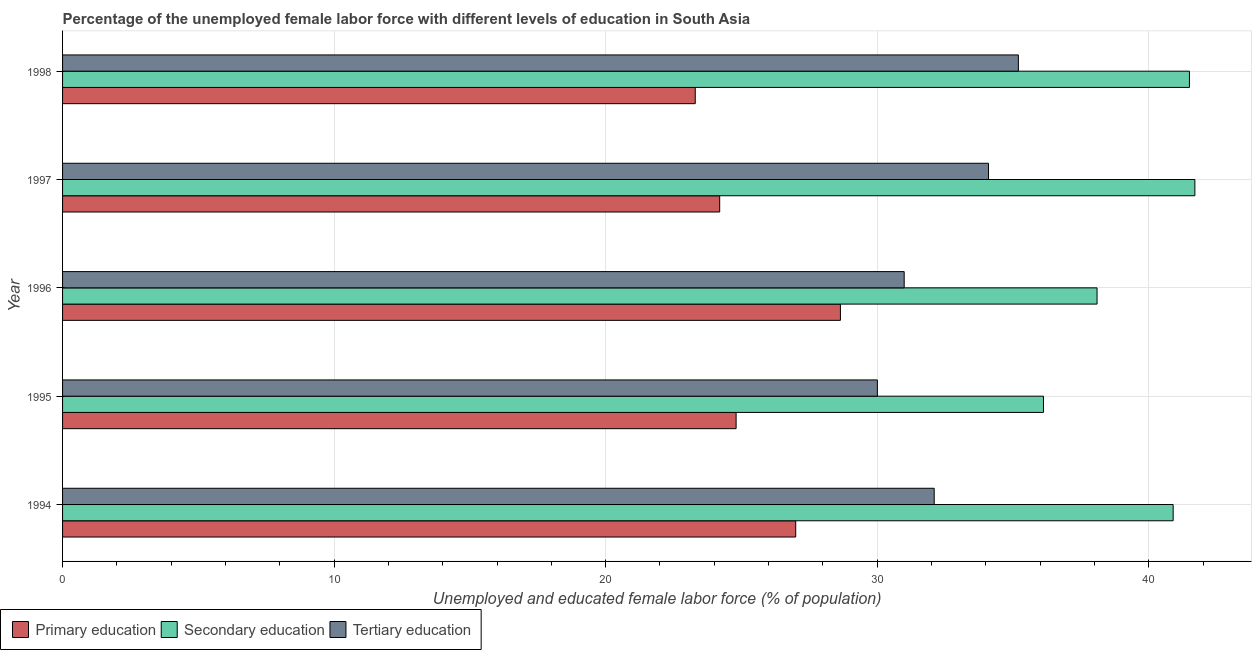How many different coloured bars are there?
Your answer should be very brief. 3. How many groups of bars are there?
Offer a terse response. 5. Are the number of bars on each tick of the Y-axis equal?
Offer a very short reply. Yes. How many bars are there on the 5th tick from the top?
Your response must be concise. 3. How many bars are there on the 2nd tick from the bottom?
Your answer should be very brief. 3. What is the label of the 1st group of bars from the top?
Make the answer very short. 1998. What is the percentage of female labor force who received tertiary education in 1997?
Keep it short and to the point. 34.1. Across all years, what is the maximum percentage of female labor force who received tertiary education?
Provide a short and direct response. 35.2. Across all years, what is the minimum percentage of female labor force who received primary education?
Your answer should be compact. 23.3. In which year was the percentage of female labor force who received secondary education maximum?
Make the answer very short. 1997. In which year was the percentage of female labor force who received tertiary education minimum?
Give a very brief answer. 1995. What is the total percentage of female labor force who received primary education in the graph?
Keep it short and to the point. 127.95. What is the difference between the percentage of female labor force who received tertiary education in 1995 and the percentage of female labor force who received primary education in 1997?
Your answer should be compact. 5.81. What is the average percentage of female labor force who received primary education per year?
Provide a short and direct response. 25.59. In the year 1998, what is the difference between the percentage of female labor force who received secondary education and percentage of female labor force who received tertiary education?
Keep it short and to the point. 6.3. In how many years, is the percentage of female labor force who received primary education greater than 32 %?
Offer a terse response. 0. What is the ratio of the percentage of female labor force who received secondary education in 1994 to that in 1995?
Your answer should be compact. 1.13. What is the difference between the highest and the second highest percentage of female labor force who received primary education?
Your answer should be compact. 1.65. What is the difference between the highest and the lowest percentage of female labor force who received tertiary education?
Provide a short and direct response. 5.19. What does the 2nd bar from the top in 1996 represents?
Ensure brevity in your answer.  Secondary education. What does the 3rd bar from the bottom in 1994 represents?
Ensure brevity in your answer.  Tertiary education. How many bars are there?
Offer a terse response. 15. Are all the bars in the graph horizontal?
Your answer should be compact. Yes. Does the graph contain any zero values?
Keep it short and to the point. No. Does the graph contain grids?
Your answer should be compact. Yes. Where does the legend appear in the graph?
Make the answer very short. Bottom left. How many legend labels are there?
Keep it short and to the point. 3. How are the legend labels stacked?
Ensure brevity in your answer.  Horizontal. What is the title of the graph?
Ensure brevity in your answer.  Percentage of the unemployed female labor force with different levels of education in South Asia. Does "Taxes" appear as one of the legend labels in the graph?
Your answer should be compact. No. What is the label or title of the X-axis?
Keep it short and to the point. Unemployed and educated female labor force (% of population). What is the Unemployed and educated female labor force (% of population) in Secondary education in 1994?
Ensure brevity in your answer.  40.9. What is the Unemployed and educated female labor force (% of population) in Tertiary education in 1994?
Provide a succinct answer. 32.1. What is the Unemployed and educated female labor force (% of population) in Primary education in 1995?
Keep it short and to the point. 24.8. What is the Unemployed and educated female labor force (% of population) of Secondary education in 1995?
Give a very brief answer. 36.12. What is the Unemployed and educated female labor force (% of population) in Tertiary education in 1995?
Offer a terse response. 30.01. What is the Unemployed and educated female labor force (% of population) of Primary education in 1996?
Offer a very short reply. 28.65. What is the Unemployed and educated female labor force (% of population) of Secondary education in 1996?
Offer a terse response. 38.1. What is the Unemployed and educated female labor force (% of population) of Tertiary education in 1996?
Ensure brevity in your answer.  30.99. What is the Unemployed and educated female labor force (% of population) of Primary education in 1997?
Your response must be concise. 24.2. What is the Unemployed and educated female labor force (% of population) in Secondary education in 1997?
Offer a very short reply. 41.7. What is the Unemployed and educated female labor force (% of population) of Tertiary education in 1997?
Your answer should be very brief. 34.1. What is the Unemployed and educated female labor force (% of population) in Primary education in 1998?
Keep it short and to the point. 23.3. What is the Unemployed and educated female labor force (% of population) in Secondary education in 1998?
Make the answer very short. 41.5. What is the Unemployed and educated female labor force (% of population) in Tertiary education in 1998?
Your response must be concise. 35.2. Across all years, what is the maximum Unemployed and educated female labor force (% of population) in Primary education?
Offer a very short reply. 28.65. Across all years, what is the maximum Unemployed and educated female labor force (% of population) of Secondary education?
Keep it short and to the point. 41.7. Across all years, what is the maximum Unemployed and educated female labor force (% of population) of Tertiary education?
Give a very brief answer. 35.2. Across all years, what is the minimum Unemployed and educated female labor force (% of population) of Primary education?
Provide a short and direct response. 23.3. Across all years, what is the minimum Unemployed and educated female labor force (% of population) in Secondary education?
Your answer should be very brief. 36.12. Across all years, what is the minimum Unemployed and educated female labor force (% of population) in Tertiary education?
Make the answer very short. 30.01. What is the total Unemployed and educated female labor force (% of population) in Primary education in the graph?
Make the answer very short. 127.95. What is the total Unemployed and educated female labor force (% of population) of Secondary education in the graph?
Keep it short and to the point. 198.32. What is the total Unemployed and educated female labor force (% of population) in Tertiary education in the graph?
Offer a terse response. 162.4. What is the difference between the Unemployed and educated female labor force (% of population) of Primary education in 1994 and that in 1995?
Your answer should be compact. 2.2. What is the difference between the Unemployed and educated female labor force (% of population) of Secondary education in 1994 and that in 1995?
Offer a terse response. 4.78. What is the difference between the Unemployed and educated female labor force (% of population) in Tertiary education in 1994 and that in 1995?
Give a very brief answer. 2.09. What is the difference between the Unemployed and educated female labor force (% of population) of Primary education in 1994 and that in 1996?
Offer a very short reply. -1.65. What is the difference between the Unemployed and educated female labor force (% of population) in Secondary education in 1994 and that in 1996?
Offer a terse response. 2.8. What is the difference between the Unemployed and educated female labor force (% of population) of Tertiary education in 1994 and that in 1996?
Your answer should be compact. 1.11. What is the difference between the Unemployed and educated female labor force (% of population) in Tertiary education in 1994 and that in 1997?
Offer a very short reply. -2. What is the difference between the Unemployed and educated female labor force (% of population) in Primary education in 1994 and that in 1998?
Your response must be concise. 3.7. What is the difference between the Unemployed and educated female labor force (% of population) in Secondary education in 1994 and that in 1998?
Give a very brief answer. -0.6. What is the difference between the Unemployed and educated female labor force (% of population) in Primary education in 1995 and that in 1996?
Make the answer very short. -3.84. What is the difference between the Unemployed and educated female labor force (% of population) of Secondary education in 1995 and that in 1996?
Make the answer very short. -1.97. What is the difference between the Unemployed and educated female labor force (% of population) of Tertiary education in 1995 and that in 1996?
Ensure brevity in your answer.  -0.99. What is the difference between the Unemployed and educated female labor force (% of population) of Primary education in 1995 and that in 1997?
Your response must be concise. 0.6. What is the difference between the Unemployed and educated female labor force (% of population) of Secondary education in 1995 and that in 1997?
Offer a very short reply. -5.58. What is the difference between the Unemployed and educated female labor force (% of population) of Tertiary education in 1995 and that in 1997?
Your answer should be compact. -4.09. What is the difference between the Unemployed and educated female labor force (% of population) in Primary education in 1995 and that in 1998?
Provide a short and direct response. 1.5. What is the difference between the Unemployed and educated female labor force (% of population) of Secondary education in 1995 and that in 1998?
Your answer should be very brief. -5.38. What is the difference between the Unemployed and educated female labor force (% of population) in Tertiary education in 1995 and that in 1998?
Keep it short and to the point. -5.19. What is the difference between the Unemployed and educated female labor force (% of population) of Primary education in 1996 and that in 1997?
Your answer should be compact. 4.45. What is the difference between the Unemployed and educated female labor force (% of population) in Secondary education in 1996 and that in 1997?
Give a very brief answer. -3.6. What is the difference between the Unemployed and educated female labor force (% of population) in Tertiary education in 1996 and that in 1997?
Your answer should be very brief. -3.11. What is the difference between the Unemployed and educated female labor force (% of population) of Primary education in 1996 and that in 1998?
Ensure brevity in your answer.  5.35. What is the difference between the Unemployed and educated female labor force (% of population) of Secondary education in 1996 and that in 1998?
Keep it short and to the point. -3.4. What is the difference between the Unemployed and educated female labor force (% of population) of Tertiary education in 1996 and that in 1998?
Keep it short and to the point. -4.21. What is the difference between the Unemployed and educated female labor force (% of population) of Primary education in 1997 and that in 1998?
Provide a succinct answer. 0.9. What is the difference between the Unemployed and educated female labor force (% of population) in Secondary education in 1997 and that in 1998?
Your answer should be compact. 0.2. What is the difference between the Unemployed and educated female labor force (% of population) of Tertiary education in 1997 and that in 1998?
Give a very brief answer. -1.1. What is the difference between the Unemployed and educated female labor force (% of population) of Primary education in 1994 and the Unemployed and educated female labor force (% of population) of Secondary education in 1995?
Ensure brevity in your answer.  -9.12. What is the difference between the Unemployed and educated female labor force (% of population) in Primary education in 1994 and the Unemployed and educated female labor force (% of population) in Tertiary education in 1995?
Provide a short and direct response. -3.01. What is the difference between the Unemployed and educated female labor force (% of population) in Secondary education in 1994 and the Unemployed and educated female labor force (% of population) in Tertiary education in 1995?
Provide a succinct answer. 10.89. What is the difference between the Unemployed and educated female labor force (% of population) of Primary education in 1994 and the Unemployed and educated female labor force (% of population) of Secondary education in 1996?
Your response must be concise. -11.1. What is the difference between the Unemployed and educated female labor force (% of population) of Primary education in 1994 and the Unemployed and educated female labor force (% of population) of Tertiary education in 1996?
Your response must be concise. -3.99. What is the difference between the Unemployed and educated female labor force (% of population) of Secondary education in 1994 and the Unemployed and educated female labor force (% of population) of Tertiary education in 1996?
Your answer should be very brief. 9.91. What is the difference between the Unemployed and educated female labor force (% of population) of Primary education in 1994 and the Unemployed and educated female labor force (% of population) of Secondary education in 1997?
Offer a very short reply. -14.7. What is the difference between the Unemployed and educated female labor force (% of population) in Secondary education in 1994 and the Unemployed and educated female labor force (% of population) in Tertiary education in 1997?
Your answer should be very brief. 6.8. What is the difference between the Unemployed and educated female labor force (% of population) of Primary education in 1994 and the Unemployed and educated female labor force (% of population) of Secondary education in 1998?
Make the answer very short. -14.5. What is the difference between the Unemployed and educated female labor force (% of population) in Secondary education in 1994 and the Unemployed and educated female labor force (% of population) in Tertiary education in 1998?
Offer a terse response. 5.7. What is the difference between the Unemployed and educated female labor force (% of population) in Primary education in 1995 and the Unemployed and educated female labor force (% of population) in Secondary education in 1996?
Make the answer very short. -13.29. What is the difference between the Unemployed and educated female labor force (% of population) in Primary education in 1995 and the Unemployed and educated female labor force (% of population) in Tertiary education in 1996?
Your answer should be very brief. -6.19. What is the difference between the Unemployed and educated female labor force (% of population) in Secondary education in 1995 and the Unemployed and educated female labor force (% of population) in Tertiary education in 1996?
Make the answer very short. 5.13. What is the difference between the Unemployed and educated female labor force (% of population) in Primary education in 1995 and the Unemployed and educated female labor force (% of population) in Secondary education in 1997?
Keep it short and to the point. -16.9. What is the difference between the Unemployed and educated female labor force (% of population) in Primary education in 1995 and the Unemployed and educated female labor force (% of population) in Tertiary education in 1997?
Provide a succinct answer. -9.3. What is the difference between the Unemployed and educated female labor force (% of population) of Secondary education in 1995 and the Unemployed and educated female labor force (% of population) of Tertiary education in 1997?
Your answer should be compact. 2.02. What is the difference between the Unemployed and educated female labor force (% of population) of Primary education in 1995 and the Unemployed and educated female labor force (% of population) of Secondary education in 1998?
Your response must be concise. -16.7. What is the difference between the Unemployed and educated female labor force (% of population) in Primary education in 1995 and the Unemployed and educated female labor force (% of population) in Tertiary education in 1998?
Keep it short and to the point. -10.4. What is the difference between the Unemployed and educated female labor force (% of population) of Secondary education in 1995 and the Unemployed and educated female labor force (% of population) of Tertiary education in 1998?
Provide a short and direct response. 0.92. What is the difference between the Unemployed and educated female labor force (% of population) in Primary education in 1996 and the Unemployed and educated female labor force (% of population) in Secondary education in 1997?
Offer a very short reply. -13.05. What is the difference between the Unemployed and educated female labor force (% of population) of Primary education in 1996 and the Unemployed and educated female labor force (% of population) of Tertiary education in 1997?
Keep it short and to the point. -5.45. What is the difference between the Unemployed and educated female labor force (% of population) in Secondary education in 1996 and the Unemployed and educated female labor force (% of population) in Tertiary education in 1997?
Give a very brief answer. 4. What is the difference between the Unemployed and educated female labor force (% of population) of Primary education in 1996 and the Unemployed and educated female labor force (% of population) of Secondary education in 1998?
Make the answer very short. -12.85. What is the difference between the Unemployed and educated female labor force (% of population) in Primary education in 1996 and the Unemployed and educated female labor force (% of population) in Tertiary education in 1998?
Offer a terse response. -6.55. What is the difference between the Unemployed and educated female labor force (% of population) of Secondary education in 1996 and the Unemployed and educated female labor force (% of population) of Tertiary education in 1998?
Provide a succinct answer. 2.9. What is the difference between the Unemployed and educated female labor force (% of population) of Primary education in 1997 and the Unemployed and educated female labor force (% of population) of Secondary education in 1998?
Offer a terse response. -17.3. What is the difference between the Unemployed and educated female labor force (% of population) in Secondary education in 1997 and the Unemployed and educated female labor force (% of population) in Tertiary education in 1998?
Offer a very short reply. 6.5. What is the average Unemployed and educated female labor force (% of population) in Primary education per year?
Offer a very short reply. 25.59. What is the average Unemployed and educated female labor force (% of population) of Secondary education per year?
Provide a short and direct response. 39.66. What is the average Unemployed and educated female labor force (% of population) of Tertiary education per year?
Make the answer very short. 32.48. In the year 1994, what is the difference between the Unemployed and educated female labor force (% of population) of Primary education and Unemployed and educated female labor force (% of population) of Tertiary education?
Provide a short and direct response. -5.1. In the year 1994, what is the difference between the Unemployed and educated female labor force (% of population) in Secondary education and Unemployed and educated female labor force (% of population) in Tertiary education?
Give a very brief answer. 8.8. In the year 1995, what is the difference between the Unemployed and educated female labor force (% of population) of Primary education and Unemployed and educated female labor force (% of population) of Secondary education?
Provide a short and direct response. -11.32. In the year 1995, what is the difference between the Unemployed and educated female labor force (% of population) of Primary education and Unemployed and educated female labor force (% of population) of Tertiary education?
Your answer should be very brief. -5.2. In the year 1995, what is the difference between the Unemployed and educated female labor force (% of population) of Secondary education and Unemployed and educated female labor force (% of population) of Tertiary education?
Offer a terse response. 6.12. In the year 1996, what is the difference between the Unemployed and educated female labor force (% of population) of Primary education and Unemployed and educated female labor force (% of population) of Secondary education?
Offer a very short reply. -9.45. In the year 1996, what is the difference between the Unemployed and educated female labor force (% of population) of Primary education and Unemployed and educated female labor force (% of population) of Tertiary education?
Your answer should be compact. -2.35. In the year 1996, what is the difference between the Unemployed and educated female labor force (% of population) in Secondary education and Unemployed and educated female labor force (% of population) in Tertiary education?
Keep it short and to the point. 7.1. In the year 1997, what is the difference between the Unemployed and educated female labor force (% of population) of Primary education and Unemployed and educated female labor force (% of population) of Secondary education?
Your response must be concise. -17.5. In the year 1997, what is the difference between the Unemployed and educated female labor force (% of population) of Primary education and Unemployed and educated female labor force (% of population) of Tertiary education?
Keep it short and to the point. -9.9. In the year 1997, what is the difference between the Unemployed and educated female labor force (% of population) of Secondary education and Unemployed and educated female labor force (% of population) of Tertiary education?
Your answer should be compact. 7.6. In the year 1998, what is the difference between the Unemployed and educated female labor force (% of population) in Primary education and Unemployed and educated female labor force (% of population) in Secondary education?
Ensure brevity in your answer.  -18.2. In the year 1998, what is the difference between the Unemployed and educated female labor force (% of population) in Secondary education and Unemployed and educated female labor force (% of population) in Tertiary education?
Keep it short and to the point. 6.3. What is the ratio of the Unemployed and educated female labor force (% of population) in Primary education in 1994 to that in 1995?
Offer a terse response. 1.09. What is the ratio of the Unemployed and educated female labor force (% of population) of Secondary education in 1994 to that in 1995?
Offer a very short reply. 1.13. What is the ratio of the Unemployed and educated female labor force (% of population) in Tertiary education in 1994 to that in 1995?
Your answer should be very brief. 1.07. What is the ratio of the Unemployed and educated female labor force (% of population) in Primary education in 1994 to that in 1996?
Your response must be concise. 0.94. What is the ratio of the Unemployed and educated female labor force (% of population) of Secondary education in 1994 to that in 1996?
Provide a succinct answer. 1.07. What is the ratio of the Unemployed and educated female labor force (% of population) in Tertiary education in 1994 to that in 1996?
Your answer should be compact. 1.04. What is the ratio of the Unemployed and educated female labor force (% of population) in Primary education in 1994 to that in 1997?
Your answer should be very brief. 1.12. What is the ratio of the Unemployed and educated female labor force (% of population) in Secondary education in 1994 to that in 1997?
Make the answer very short. 0.98. What is the ratio of the Unemployed and educated female labor force (% of population) in Tertiary education in 1994 to that in 1997?
Your answer should be very brief. 0.94. What is the ratio of the Unemployed and educated female labor force (% of population) in Primary education in 1994 to that in 1998?
Offer a very short reply. 1.16. What is the ratio of the Unemployed and educated female labor force (% of population) in Secondary education in 1994 to that in 1998?
Your answer should be very brief. 0.99. What is the ratio of the Unemployed and educated female labor force (% of population) in Tertiary education in 1994 to that in 1998?
Your response must be concise. 0.91. What is the ratio of the Unemployed and educated female labor force (% of population) in Primary education in 1995 to that in 1996?
Offer a terse response. 0.87. What is the ratio of the Unemployed and educated female labor force (% of population) of Secondary education in 1995 to that in 1996?
Provide a succinct answer. 0.95. What is the ratio of the Unemployed and educated female labor force (% of population) in Tertiary education in 1995 to that in 1996?
Keep it short and to the point. 0.97. What is the ratio of the Unemployed and educated female labor force (% of population) in Primary education in 1995 to that in 1997?
Keep it short and to the point. 1.02. What is the ratio of the Unemployed and educated female labor force (% of population) in Secondary education in 1995 to that in 1997?
Provide a short and direct response. 0.87. What is the ratio of the Unemployed and educated female labor force (% of population) in Primary education in 1995 to that in 1998?
Ensure brevity in your answer.  1.06. What is the ratio of the Unemployed and educated female labor force (% of population) in Secondary education in 1995 to that in 1998?
Ensure brevity in your answer.  0.87. What is the ratio of the Unemployed and educated female labor force (% of population) of Tertiary education in 1995 to that in 1998?
Your response must be concise. 0.85. What is the ratio of the Unemployed and educated female labor force (% of population) of Primary education in 1996 to that in 1997?
Make the answer very short. 1.18. What is the ratio of the Unemployed and educated female labor force (% of population) of Secondary education in 1996 to that in 1997?
Provide a short and direct response. 0.91. What is the ratio of the Unemployed and educated female labor force (% of population) of Tertiary education in 1996 to that in 1997?
Offer a terse response. 0.91. What is the ratio of the Unemployed and educated female labor force (% of population) in Primary education in 1996 to that in 1998?
Offer a very short reply. 1.23. What is the ratio of the Unemployed and educated female labor force (% of population) in Secondary education in 1996 to that in 1998?
Make the answer very short. 0.92. What is the ratio of the Unemployed and educated female labor force (% of population) of Tertiary education in 1996 to that in 1998?
Keep it short and to the point. 0.88. What is the ratio of the Unemployed and educated female labor force (% of population) of Primary education in 1997 to that in 1998?
Offer a terse response. 1.04. What is the ratio of the Unemployed and educated female labor force (% of population) in Secondary education in 1997 to that in 1998?
Ensure brevity in your answer.  1. What is the ratio of the Unemployed and educated female labor force (% of population) in Tertiary education in 1997 to that in 1998?
Provide a succinct answer. 0.97. What is the difference between the highest and the second highest Unemployed and educated female labor force (% of population) in Primary education?
Give a very brief answer. 1.65. What is the difference between the highest and the second highest Unemployed and educated female labor force (% of population) in Secondary education?
Ensure brevity in your answer.  0.2. What is the difference between the highest and the second highest Unemployed and educated female labor force (% of population) of Tertiary education?
Make the answer very short. 1.1. What is the difference between the highest and the lowest Unemployed and educated female labor force (% of population) in Primary education?
Provide a succinct answer. 5.35. What is the difference between the highest and the lowest Unemployed and educated female labor force (% of population) of Secondary education?
Offer a very short reply. 5.58. What is the difference between the highest and the lowest Unemployed and educated female labor force (% of population) in Tertiary education?
Provide a short and direct response. 5.19. 